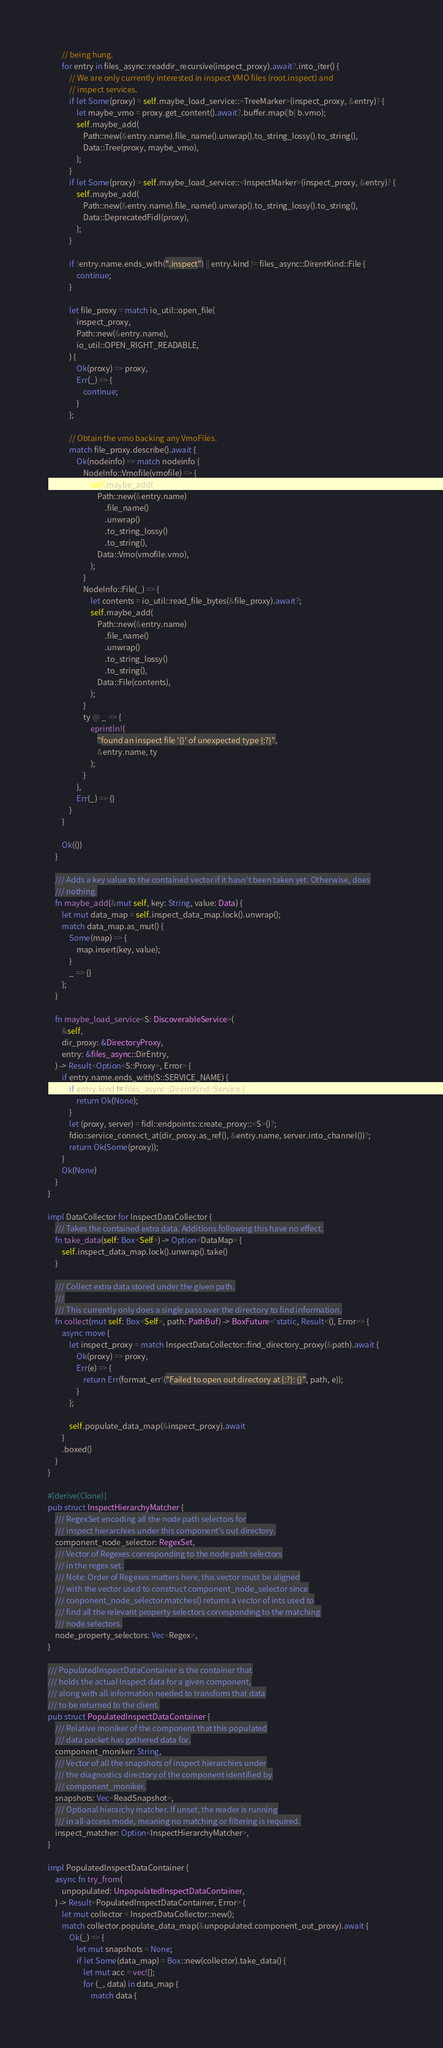Convert code to text. <code><loc_0><loc_0><loc_500><loc_500><_Rust_>        // being hung.
        for entry in files_async::readdir_recursive(inspect_proxy).await?.into_iter() {
            // We are only currently interested in inspect VMO files (root.inspect) and
            // inspect services.
            if let Some(proxy) = self.maybe_load_service::<TreeMarker>(inspect_proxy, &entry)? {
                let maybe_vmo = proxy.get_content().await?.buffer.map(|b| b.vmo);
                self.maybe_add(
                    Path::new(&entry.name).file_name().unwrap().to_string_lossy().to_string(),
                    Data::Tree(proxy, maybe_vmo),
                );
            }
            if let Some(proxy) = self.maybe_load_service::<InspectMarker>(inspect_proxy, &entry)? {
                self.maybe_add(
                    Path::new(&entry.name).file_name().unwrap().to_string_lossy().to_string(),
                    Data::DeprecatedFidl(proxy),
                );
            }

            if !entry.name.ends_with(".inspect") || entry.kind != files_async::DirentKind::File {
                continue;
            }

            let file_proxy = match io_util::open_file(
                inspect_proxy,
                Path::new(&entry.name),
                io_util::OPEN_RIGHT_READABLE,
            ) {
                Ok(proxy) => proxy,
                Err(_) => {
                    continue;
                }
            };

            // Obtain the vmo backing any VmoFiles.
            match file_proxy.describe().await {
                Ok(nodeinfo) => match nodeinfo {
                    NodeInfo::Vmofile(vmofile) => {
                        self.maybe_add(
                            Path::new(&entry.name)
                                .file_name()
                                .unwrap()
                                .to_string_lossy()
                                .to_string(),
                            Data::Vmo(vmofile.vmo),
                        );
                    }
                    NodeInfo::File(_) => {
                        let contents = io_util::read_file_bytes(&file_proxy).await?;
                        self.maybe_add(
                            Path::new(&entry.name)
                                .file_name()
                                .unwrap()
                                .to_string_lossy()
                                .to_string(),
                            Data::File(contents),
                        );
                    }
                    ty @ _ => {
                        eprintln!(
                            "found an inspect file '{}' of unexpected type {:?}",
                            &entry.name, ty
                        );
                    }
                },
                Err(_) => {}
            }
        }

        Ok(())
    }

    /// Adds a key value to the contained vector if it hasn't been taken yet. Otherwise, does
    /// nothing.
    fn maybe_add(&mut self, key: String, value: Data) {
        let mut data_map = self.inspect_data_map.lock().unwrap();
        match data_map.as_mut() {
            Some(map) => {
                map.insert(key, value);
            }
            _ => {}
        };
    }

    fn maybe_load_service<S: DiscoverableService>(
        &self,
        dir_proxy: &DirectoryProxy,
        entry: &files_async::DirEntry,
    ) -> Result<Option<S::Proxy>, Error> {
        if entry.name.ends_with(S::SERVICE_NAME) {
            if entry.kind != files_async::DirentKind::Service {
                return Ok(None);
            }
            let (proxy, server) = fidl::endpoints::create_proxy::<S>()?;
            fdio::service_connect_at(dir_proxy.as_ref(), &entry.name, server.into_channel())?;
            return Ok(Some(proxy));
        }
        Ok(None)
    }
}

impl DataCollector for InspectDataCollector {
    /// Takes the contained extra data. Additions following this have no effect.
    fn take_data(self: Box<Self>) -> Option<DataMap> {
        self.inspect_data_map.lock().unwrap().take()
    }

    /// Collect extra data stored under the given path.
    ///
    /// This currently only does a single pass over the directory to find information.
    fn collect(mut self: Box<Self>, path: PathBuf) -> BoxFuture<'static, Result<(), Error>> {
        async move {
            let inspect_proxy = match InspectDataCollector::find_directory_proxy(&path).await {
                Ok(proxy) => proxy,
                Err(e) => {
                    return Err(format_err!("Failed to open out directory at {:?}: {}", path, e));
                }
            };

            self.populate_data_map(&inspect_proxy).await
        }
        .boxed()
    }
}

#[derive(Clone)]
pub struct InspectHierarchyMatcher {
    /// RegexSet encoding all the node path selectors for
    /// inspect hierarchies under this component's out directory.
    component_node_selector: RegexSet,
    /// Vector of Regexes corresponding to the node path selectors
    /// in the regex set.
    /// Note: Order of Regexes matters here, this vector must be aligned
    /// with the vector used to construct component_node_selector since
    /// conponent_node_selector.matches() returns a vector of ints used to
    /// find all the relevant property selectors corresponding to the matching
    /// node selectors.
    node_property_selectors: Vec<Regex>,
}

/// PopulatedInspectDataContainer is the container that
/// holds the actual Inspect data for a given component,
/// along with all information needed to transform that data
/// to be returned to the client.
pub struct PopulatedInspectDataContainer {
    /// Relative moniker of the component that this populated
    /// data packet has gathered data for.
    component_moniker: String,
    /// Vector of all the snapshots of inspect hierarchies under
    /// the diagnostics directory of the component identified by
    /// component_moniker.
    snapshots: Vec<ReadSnapshot>,
    /// Optional hierarchy matcher. If unset, the reader is running
    /// in all-access mode, meaning no matching or filtering is required.
    inspect_matcher: Option<InspectHierarchyMatcher>,
}

impl PopulatedInspectDataContainer {
    async fn try_from(
        unpopulated: UnpopulatedInspectDataContainer,
    ) -> Result<PopulatedInspectDataContainer, Error> {
        let mut collector = InspectDataCollector::new();
        match collector.populate_data_map(&unpopulated.component_out_proxy).await {
            Ok(_) => {
                let mut snapshots = None;
                if let Some(data_map) = Box::new(collector).take_data() {
                    let mut acc = vec![];
                    for (_, data) in data_map {
                        match data {</code> 